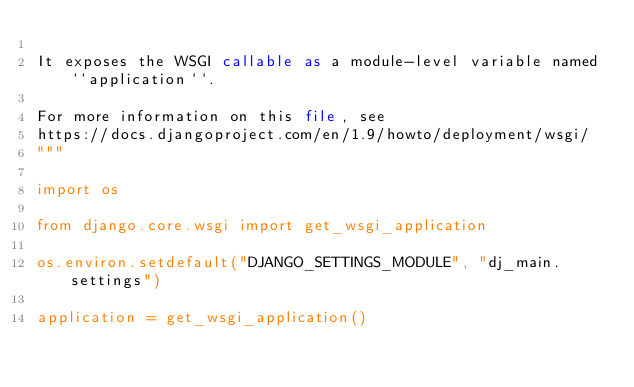<code> <loc_0><loc_0><loc_500><loc_500><_Python_>
It exposes the WSGI callable as a module-level variable named ``application``.

For more information on this file, see
https://docs.djangoproject.com/en/1.9/howto/deployment/wsgi/
"""

import os

from django.core.wsgi import get_wsgi_application

os.environ.setdefault("DJANGO_SETTINGS_MODULE", "dj_main.settings")

application = get_wsgi_application()
</code> 